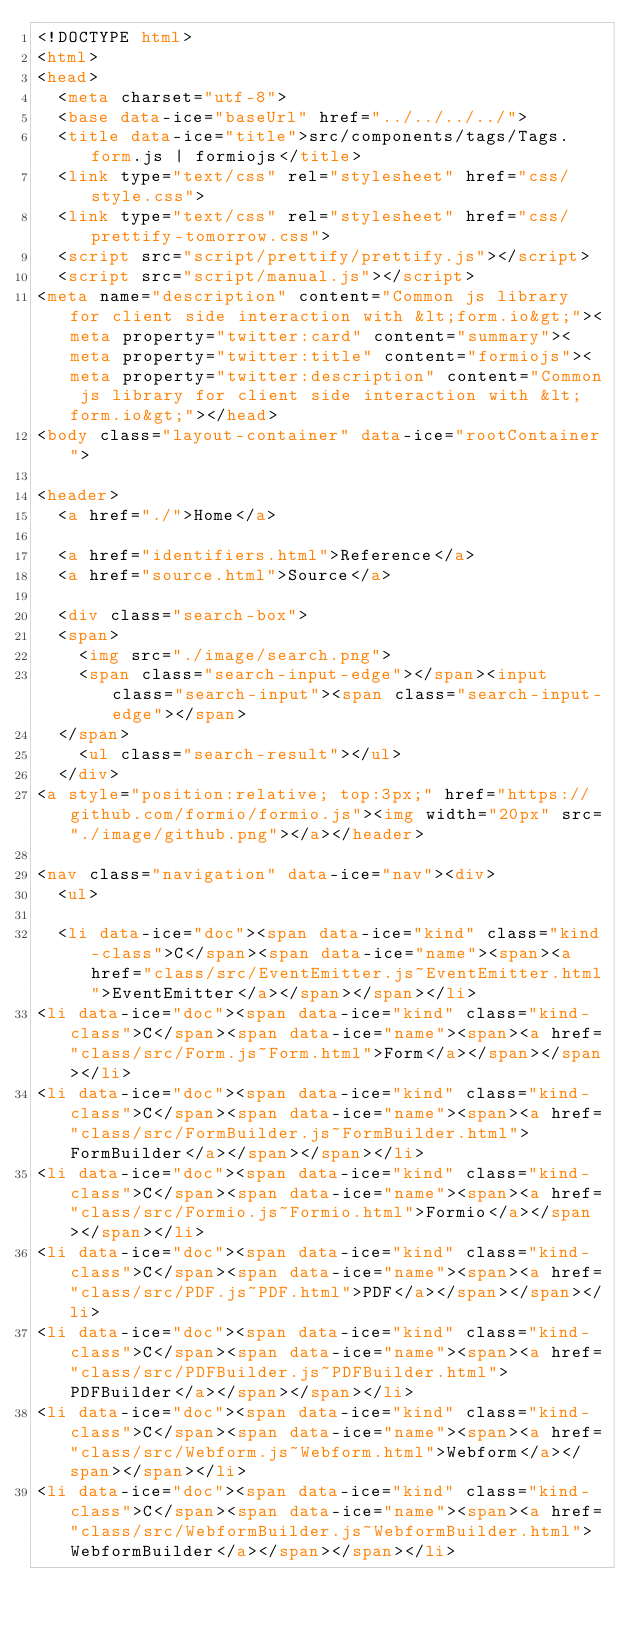Convert code to text. <code><loc_0><loc_0><loc_500><loc_500><_HTML_><!DOCTYPE html>
<html>
<head>
  <meta charset="utf-8">
  <base data-ice="baseUrl" href="../../../../">
  <title data-ice="title">src/components/tags/Tags.form.js | formiojs</title>
  <link type="text/css" rel="stylesheet" href="css/style.css">
  <link type="text/css" rel="stylesheet" href="css/prettify-tomorrow.css">
  <script src="script/prettify/prettify.js"></script>
  <script src="script/manual.js"></script>
<meta name="description" content="Common js library for client side interaction with &lt;form.io&gt;"><meta property="twitter:card" content="summary"><meta property="twitter:title" content="formiojs"><meta property="twitter:description" content="Common js library for client side interaction with &lt;form.io&gt;"></head>
<body class="layout-container" data-ice="rootContainer">

<header>
  <a href="./">Home</a>
  
  <a href="identifiers.html">Reference</a>
  <a href="source.html">Source</a>
  
  <div class="search-box">
  <span>
    <img src="./image/search.png">
    <span class="search-input-edge"></span><input class="search-input"><span class="search-input-edge"></span>
  </span>
    <ul class="search-result"></ul>
  </div>
<a style="position:relative; top:3px;" href="https://github.com/formio/formio.js"><img width="20px" src="./image/github.png"></a></header>

<nav class="navigation" data-ice="nav"><div>
  <ul>
    
  <li data-ice="doc"><span data-ice="kind" class="kind-class">C</span><span data-ice="name"><span><a href="class/src/EventEmitter.js~EventEmitter.html">EventEmitter</a></span></span></li>
<li data-ice="doc"><span data-ice="kind" class="kind-class">C</span><span data-ice="name"><span><a href="class/src/Form.js~Form.html">Form</a></span></span></li>
<li data-ice="doc"><span data-ice="kind" class="kind-class">C</span><span data-ice="name"><span><a href="class/src/FormBuilder.js~FormBuilder.html">FormBuilder</a></span></span></li>
<li data-ice="doc"><span data-ice="kind" class="kind-class">C</span><span data-ice="name"><span><a href="class/src/Formio.js~Formio.html">Formio</a></span></span></li>
<li data-ice="doc"><span data-ice="kind" class="kind-class">C</span><span data-ice="name"><span><a href="class/src/PDF.js~PDF.html">PDF</a></span></span></li>
<li data-ice="doc"><span data-ice="kind" class="kind-class">C</span><span data-ice="name"><span><a href="class/src/PDFBuilder.js~PDFBuilder.html">PDFBuilder</a></span></span></li>
<li data-ice="doc"><span data-ice="kind" class="kind-class">C</span><span data-ice="name"><span><a href="class/src/Webform.js~Webform.html">Webform</a></span></span></li>
<li data-ice="doc"><span data-ice="kind" class="kind-class">C</span><span data-ice="name"><span><a href="class/src/WebformBuilder.js~WebformBuilder.html">WebformBuilder</a></span></span></li></code> 